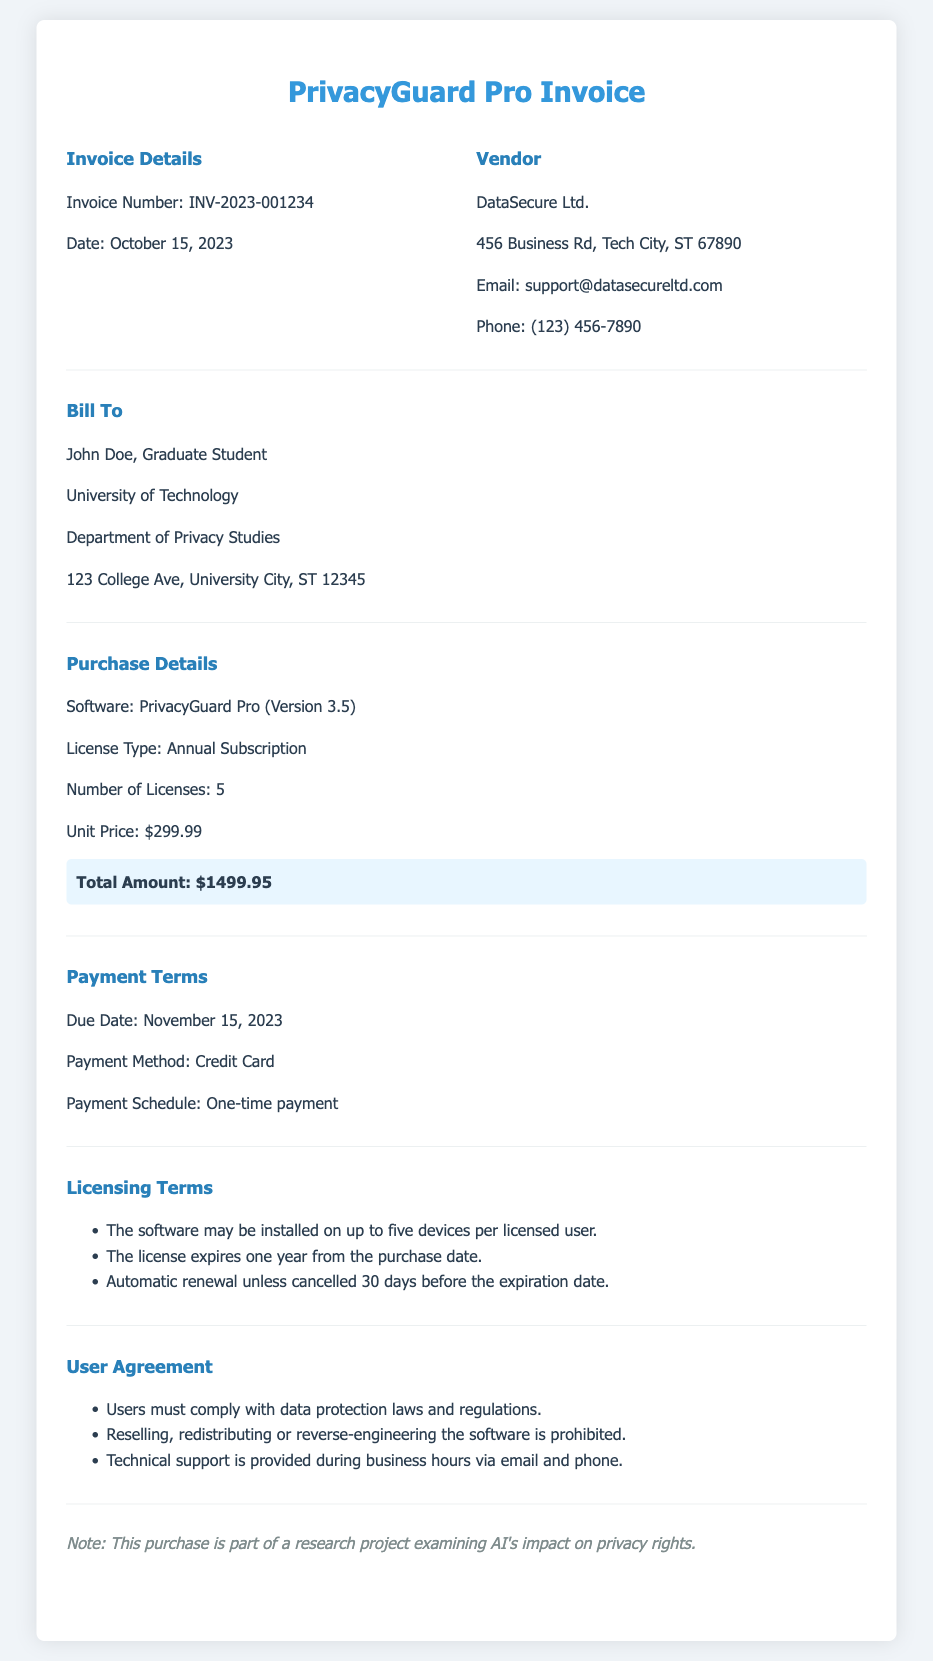What is the invoice number? The invoice number is stated in the invoice details section.
Answer: INV-2023-001234 What is the date of the invoice? The date of the invoice is also found in the invoice details section.
Answer: October 15, 2023 Who is the vendor for the software? The vendor's name is listed in the vendor section of the document.
Answer: DataSecure Ltd What is the total amount due for the purchase? The total amount is highlighted in the purchase details section.
Answer: $1499.95 What is the unit price of each license? The unit price is mentioned in the purchase details section.
Answer: $299.99 What type of license is provided for PrivacyGuard Pro? The license type is specified in the purchase details section.
Answer: Annual Subscription How many devices can the software be installed on per licensed user? The licensing terms mention this specific information.
Answer: five devices When is the payment due date? The due date for payment is stated in the payment terms section.
Answer: November 15, 2023 What is prohibited under the user agreement? The user agreement section lists what is prohibited.
Answer: Reselling, redistributing or reverse-engineering the software is prohibited 